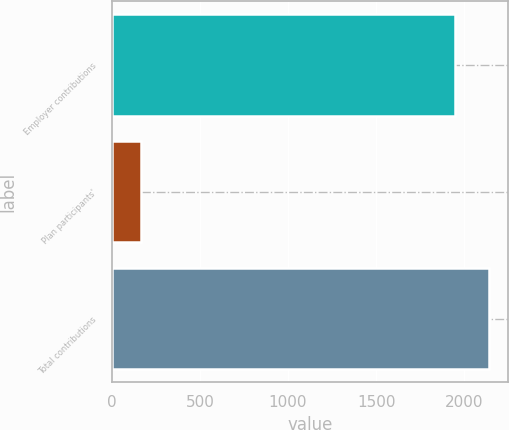<chart> <loc_0><loc_0><loc_500><loc_500><bar_chart><fcel>Employer contributions<fcel>Plan participants'<fcel>Total contributions<nl><fcel>1947<fcel>169<fcel>2141.7<nl></chart> 